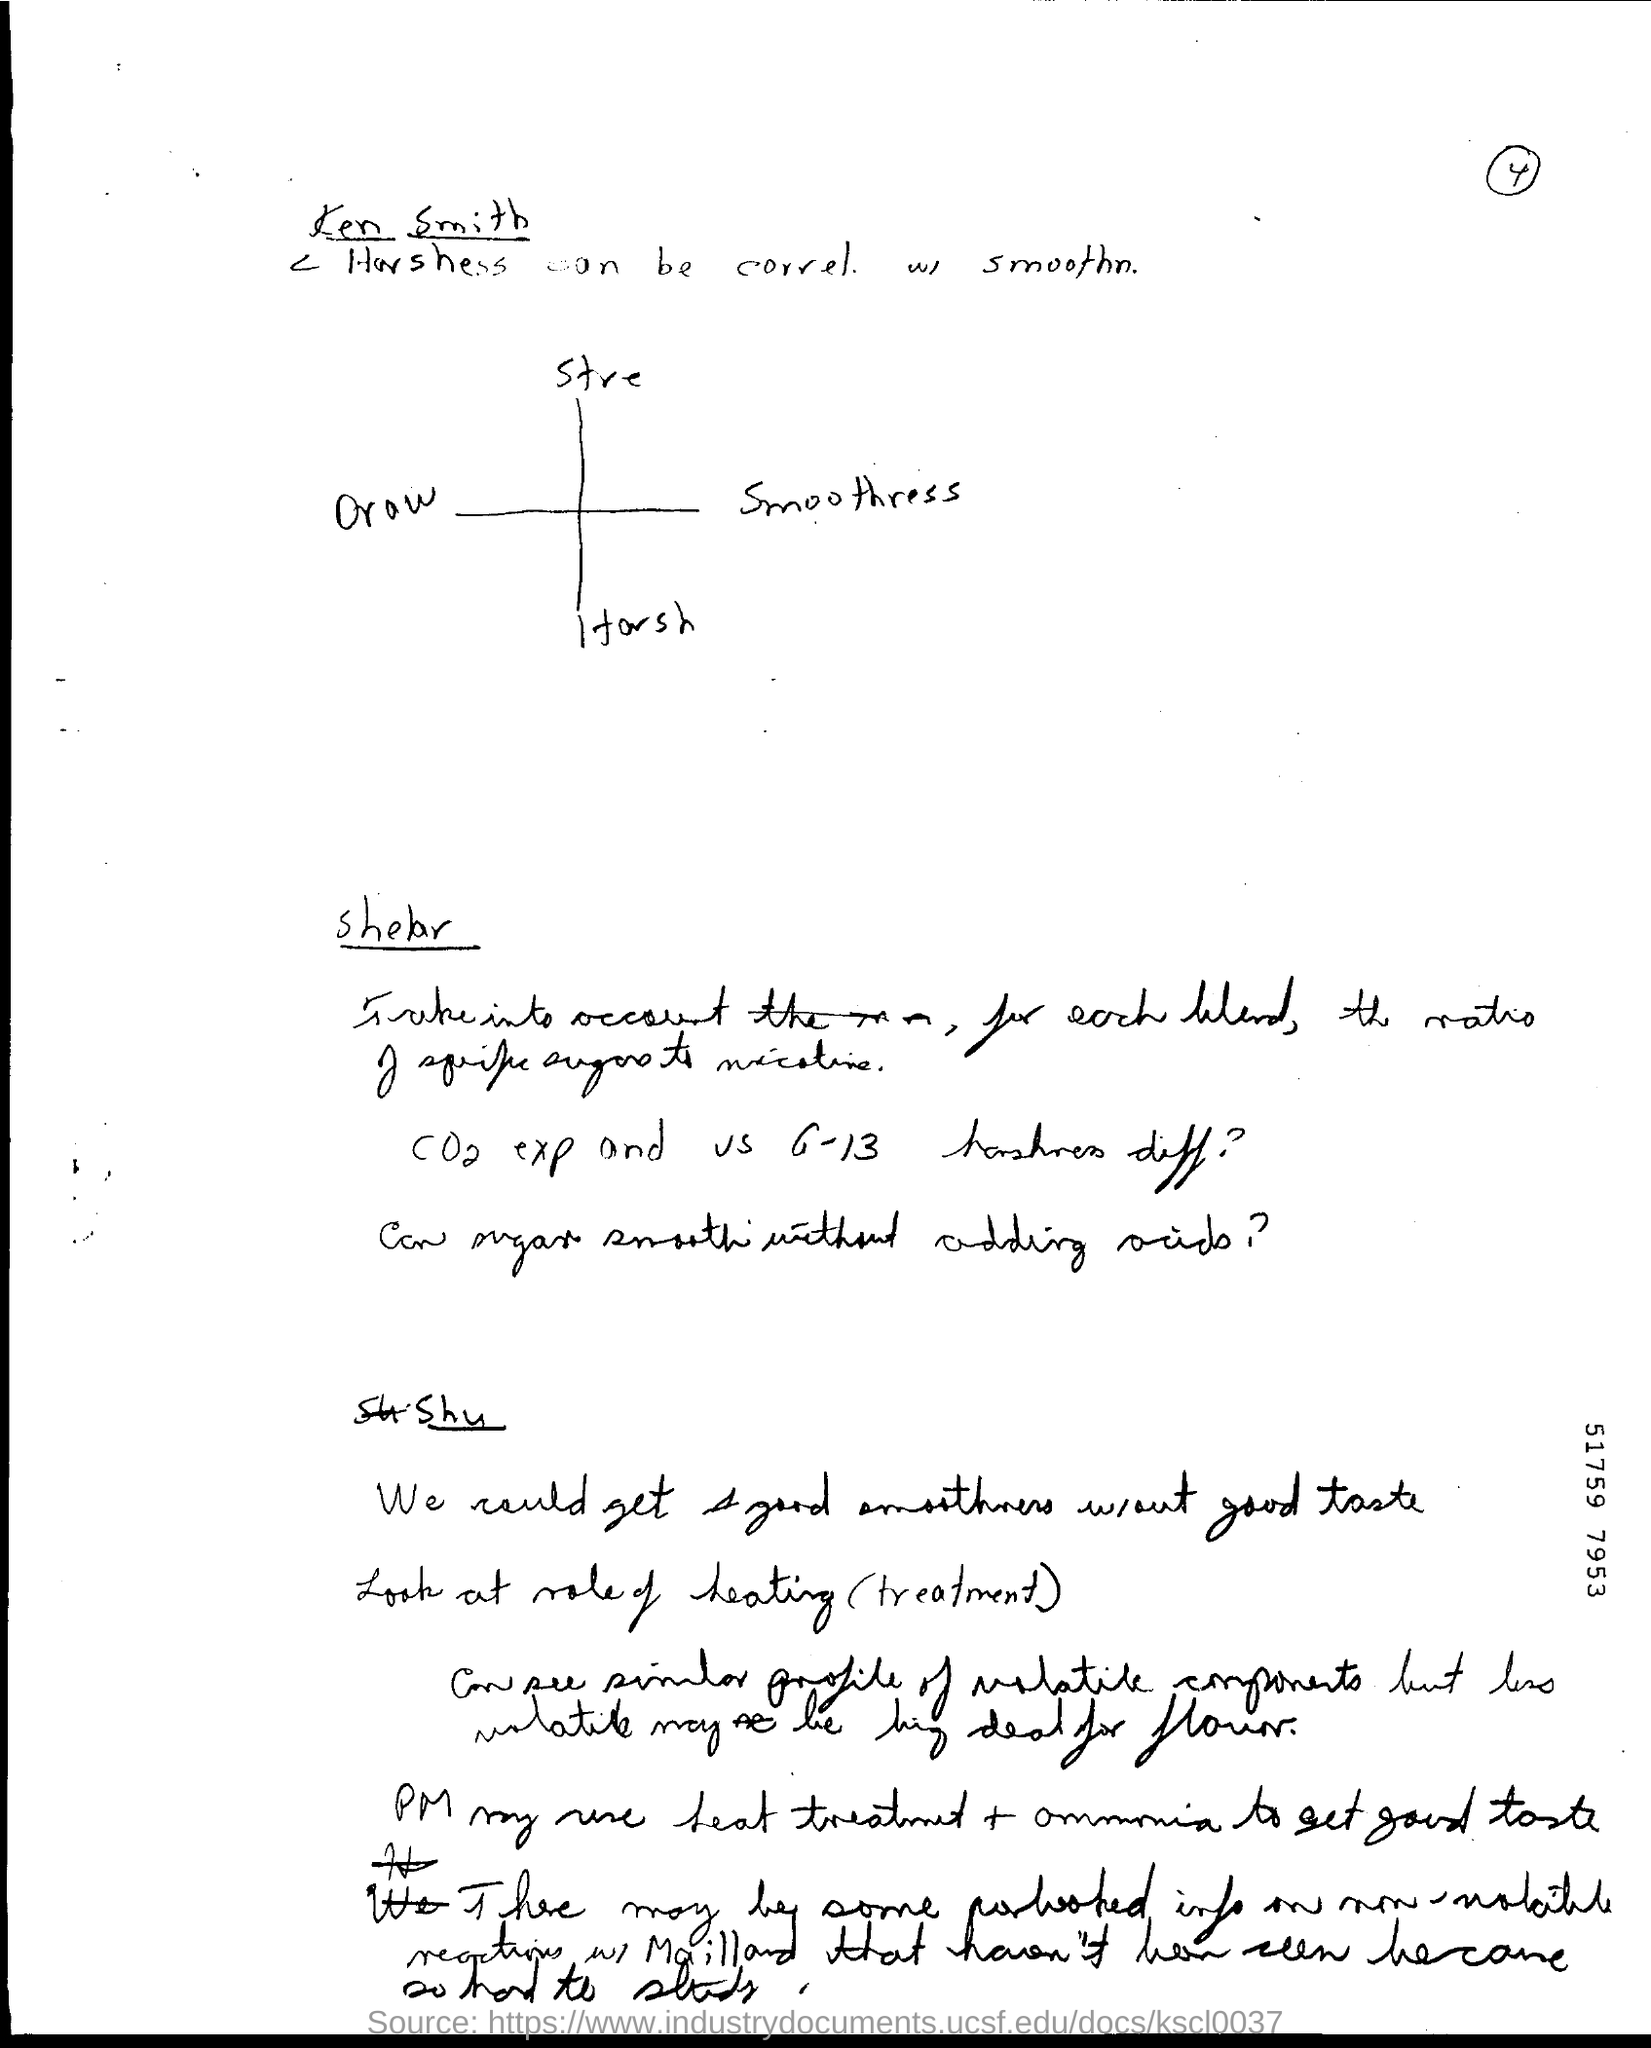List a handful of essential elements in this visual. The heading for the first side of the document is 'Ken Smith.' 